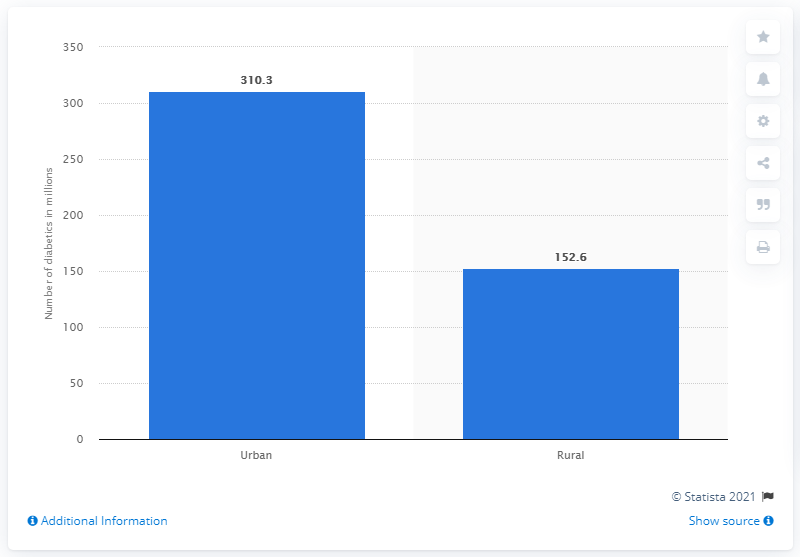Indicate a few pertinent items in this graphic. In urban areas, there are more diabetics than in rural areas. Specifically, there are 157.7 diabetics per 1000 people in urban areas, while there are only 107.3 diabetics per 1000 people in rural areas. In 2019, an estimated 310.3 million people worldwide lived with diabetes in urban areas. The location with the least number of diabetics is rural. 